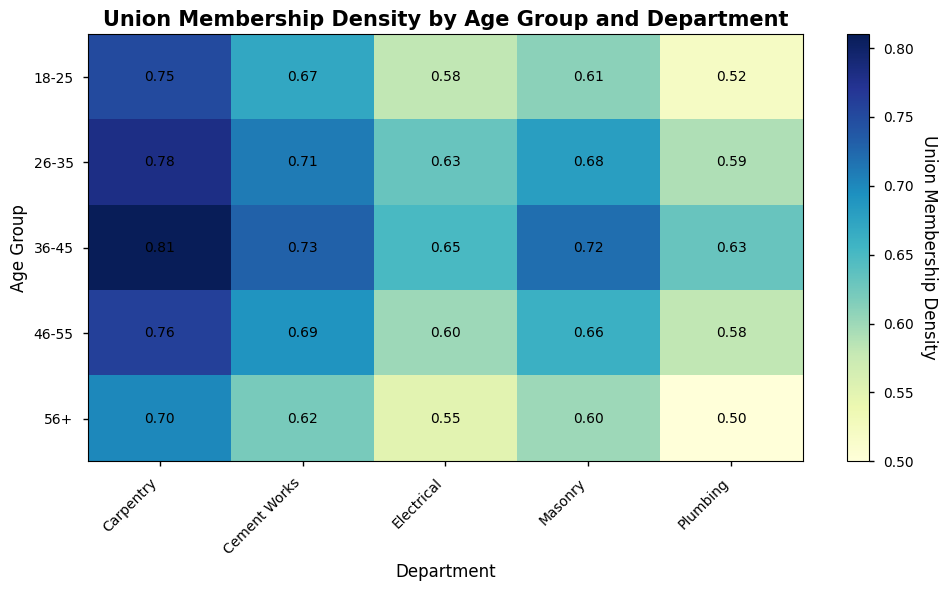What is the highest union membership density among all departments and age groups? To find the highest union membership density, visually scan the figure for the deepest color indicating the highest value. In this case, Carpentry for the 36-45 age group shows the highest density at 0.81.
Answer: 0.81 Which department has the least union membership density for the 56+ age group? For the 56+ age group, compare the colors representing the different departments. Plumbing has the lightest color, representing the lowest density at 0.50.
Answer: Plumbing What is the average union membership density for the Electrical department across all age groups? Calculate the average by summing the densities for Electrical across all age groups (0.58 + 0.63 + 0.65 + 0.60 + 0.55) and dividing by the number of age groups (5). The calculation is (0.58 + 0.63 + 0.65 + 0.60 + 0.55) / 5 = 3.01 / 5 = 0.60.
Answer: 0.60 Which age group has the most consistent union membership densities across all departments? Consistency can be visually assessed by looking at the uniformity of the colors within an age group row. The 46-55 and 18-25 age groups have relatively consistent color shades, but 46-55 shows slightly more uniform values between 0.58 and 0.69.
Answer: 46-55 Is there a department where the union membership density generally decreases with increasing age groups? Scan for a department where the color becomes progressively lighter as the age group increases. Electrical shows this pattern where densities decrease from 0.58 to 0.55 as age groups progress.
Answer: Electrical Compare the union membership density for the Masonry department between the 18-25 and 46-55 age groups. Which one is higher? Compare the values for Masonry between the two age groups. The 46-55 age group has a density of 0.66, while the 18-25 age group has a density of 0.61.
Answer: 46-55 Which age group has the lowest union membership density for the Carpentry department? Identify the age group with the lightest color in the Carpentry column. The 56+ age group has the lowest density at 0.70.
Answer: 56+ What is the difference in union membership density between the Carpentry and Plumbing departments for the 26-35 age group? Subtract the density for Plumbing (0.59) from the density for Carpentry (0.78) in the 26-35 age group. The calculation is 0.78 - 0.59 = 0.19.
Answer: 0.19 For the 36-45 age group, which department shows the second-highest union membership density? Look at the densities for the 36-45 age group and find the highest two; Carpentry is highest at 0.81 and Cement Works is the second highest at 0.73.
Answer: Cement Works 